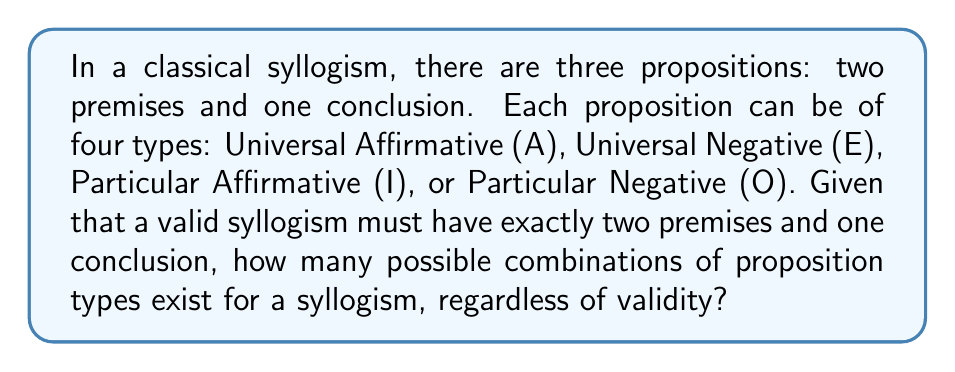Provide a solution to this math problem. Let's approach this step-by-step:

1) First, we need to understand that we are choosing the type for each of the three propositions (two premises and one conclusion) independently.

2) For each proposition, we have 4 choices (A, E, I, or O).

3) This scenario is a perfect application of the multiplication principle in combinatorics. When we have a series of independent choices, we multiply the number of options for each choice.

4) In this case, we have:
   - 4 choices for the first premise
   - 4 choices for the second premise
   - 4 choices for the conclusion

5) Therefore, the total number of possible combinations is:

   $$ 4 \times 4 \times 4 = 4^3 = 64 $$

6) It's important to note that this calculation includes all possible combinations, regardless of whether they form valid syllogisms or not. The study of which of these are actually valid would fall under the realm of logic rather than pure combinatorics.
Answer: $64$ 